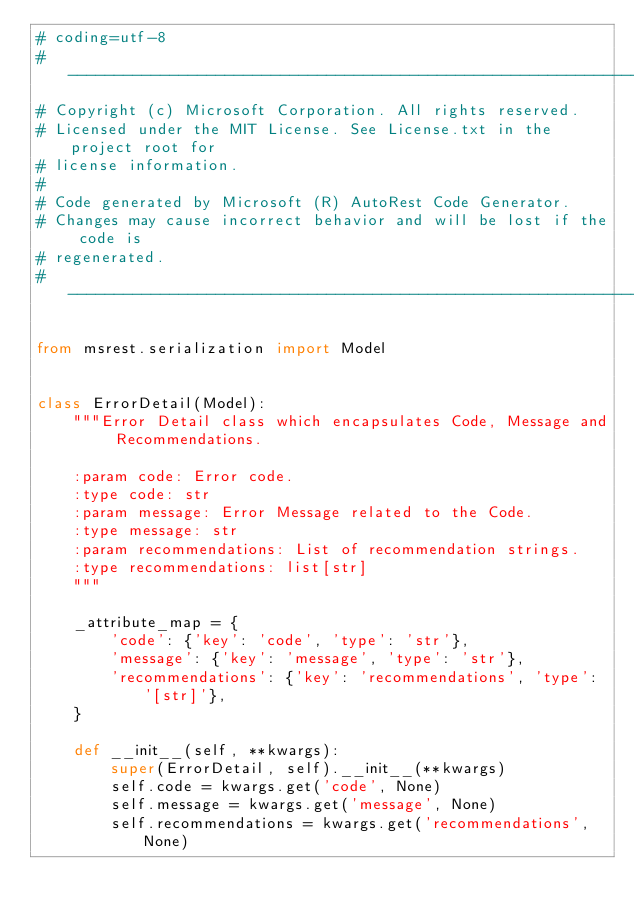<code> <loc_0><loc_0><loc_500><loc_500><_Python_># coding=utf-8
# --------------------------------------------------------------------------
# Copyright (c) Microsoft Corporation. All rights reserved.
# Licensed under the MIT License. See License.txt in the project root for
# license information.
#
# Code generated by Microsoft (R) AutoRest Code Generator.
# Changes may cause incorrect behavior and will be lost if the code is
# regenerated.
# --------------------------------------------------------------------------

from msrest.serialization import Model


class ErrorDetail(Model):
    """Error Detail class which encapsulates Code, Message and Recommendations.

    :param code: Error code.
    :type code: str
    :param message: Error Message related to the Code.
    :type message: str
    :param recommendations: List of recommendation strings.
    :type recommendations: list[str]
    """

    _attribute_map = {
        'code': {'key': 'code', 'type': 'str'},
        'message': {'key': 'message', 'type': 'str'},
        'recommendations': {'key': 'recommendations', 'type': '[str]'},
    }

    def __init__(self, **kwargs):
        super(ErrorDetail, self).__init__(**kwargs)
        self.code = kwargs.get('code', None)
        self.message = kwargs.get('message', None)
        self.recommendations = kwargs.get('recommendations', None)
</code> 